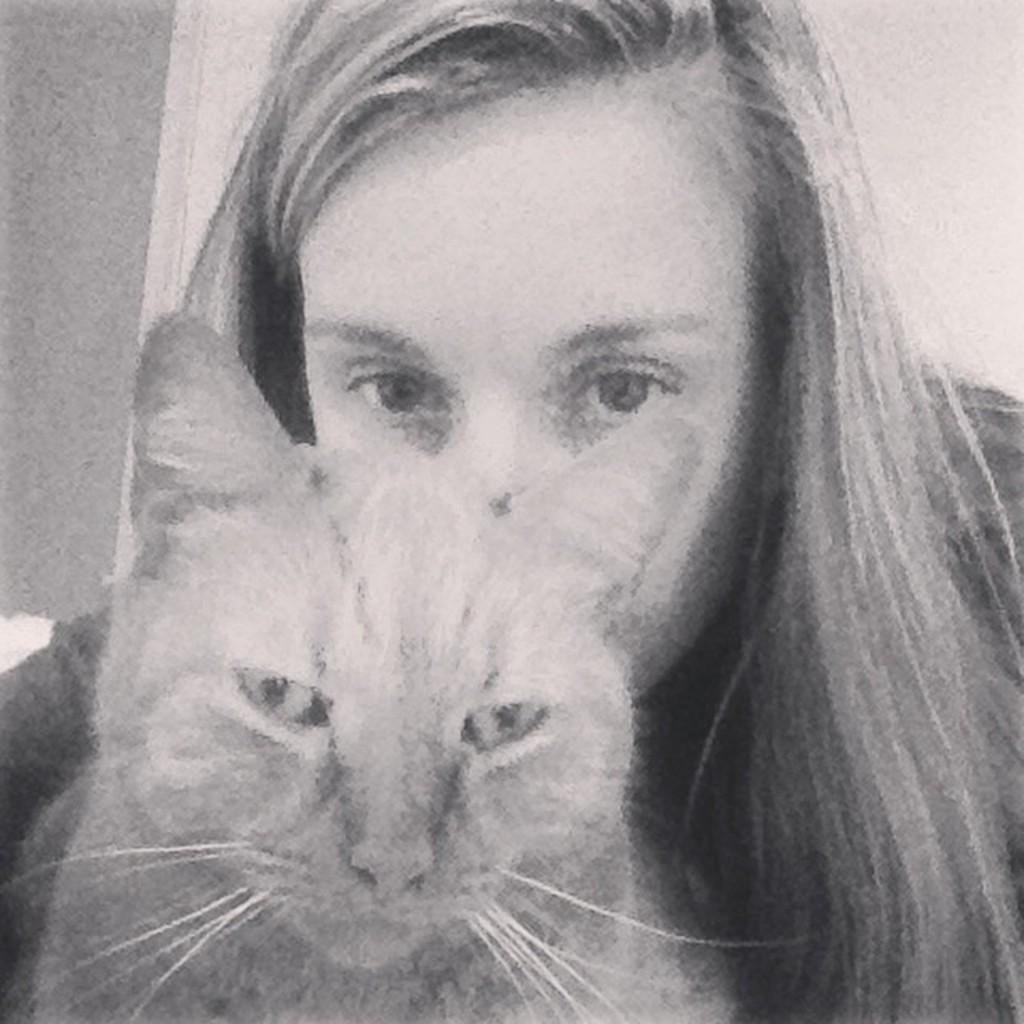Who is present in the image? There is a woman in the image. What type of animal can be seen in the image? There is a cat in the image. How many birds are in the image? There are no birds present in the image; it features a woman and a cat. What type of dress is the woman wearing in the image? The provided facts do not mention the woman's dress, so we cannot answer this question definitively. 